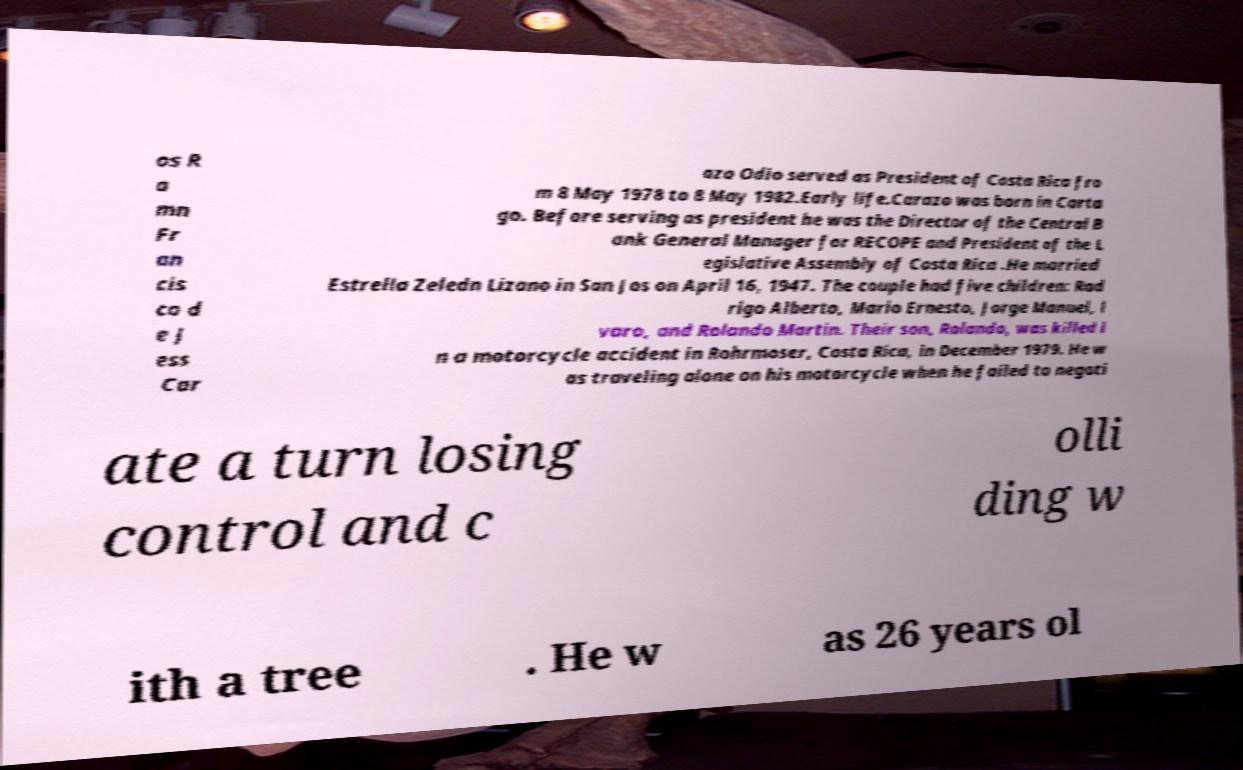Please identify and transcribe the text found in this image. os R a mn Fr an cis co d e J ess Car azo Odio served as President of Costa Rica fro m 8 May 1978 to 8 May 1982.Early life.Carazo was born in Carta go. Before serving as president he was the Director of the Central B ank General Manager for RECOPE and President of the L egislative Assembly of Costa Rica .He married Estrella Zeledn Lizano in San Jos on April 16, 1947. The couple had five children: Rod rigo Alberto, Mario Ernesto, Jorge Manuel, l varo, and Rolando Martin. Their son, Rolando, was killed i n a motorcycle accident in Rohrmoser, Costa Rica, in December 1979. He w as traveling alone on his motorcycle when he failed to negoti ate a turn losing control and c olli ding w ith a tree . He w as 26 years ol 